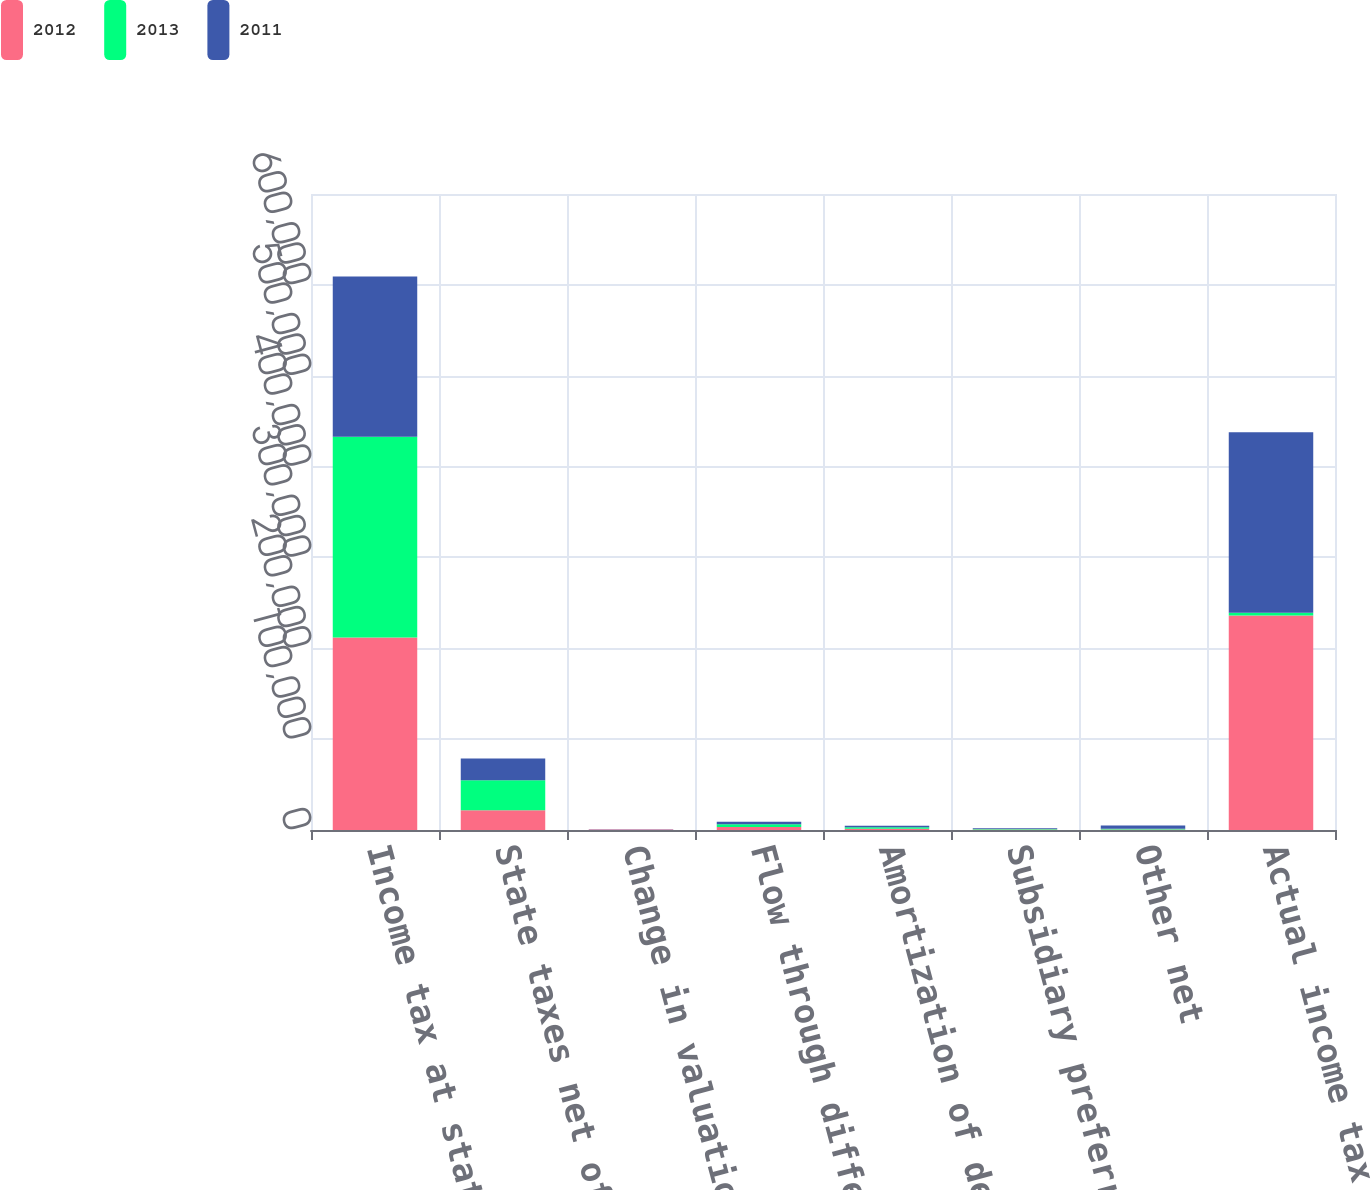Convert chart to OTSL. <chart><loc_0><loc_0><loc_500><loc_500><stacked_bar_chart><ecel><fcel>Income tax at statutory rate<fcel>State taxes net of federal<fcel>Change in valuation allowance<fcel>Flow through differences<fcel>Amortization of deferred<fcel>Subsidiary preferred dividends<fcel>Other net<fcel>Actual income tax expense<nl><fcel>2012<fcel>211914<fcel>21852<fcel>455<fcel>3217<fcel>1501<fcel>584<fcel>595<fcel>236206<nl><fcel>2013<fcel>220940<fcel>32877<fcel>143<fcel>3032<fcel>1518<fcel>634<fcel>900<fcel>2895<nl><fcel>2011<fcel>176288<fcel>24027<fcel>160<fcel>2895<fcel>1542<fcel>668<fcel>3425<fcel>198751<nl></chart> 